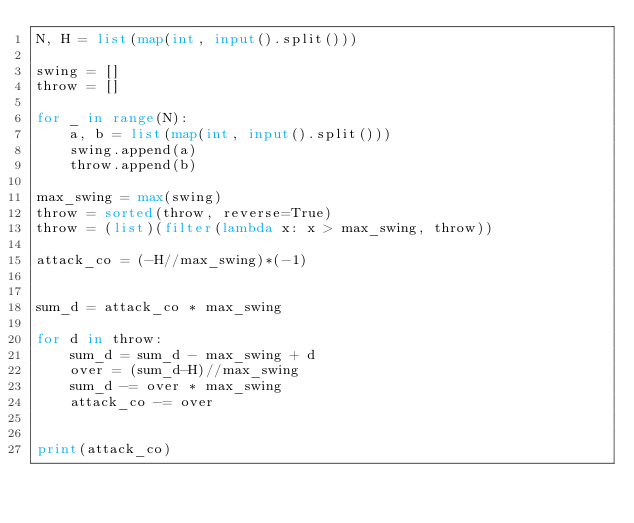<code> <loc_0><loc_0><loc_500><loc_500><_Python_>N, H = list(map(int, input().split()))

swing = []
throw = []

for _ in range(N):
    a, b = list(map(int, input().split()))
    swing.append(a)
    throw.append(b)

max_swing = max(swing)
throw = sorted(throw, reverse=True)
throw = (list)(filter(lambda x: x > max_swing, throw))

attack_co = (-H//max_swing)*(-1)


sum_d = attack_co * max_swing

for d in throw:
    sum_d = sum_d - max_swing + d
    over = (sum_d-H)//max_swing
    sum_d -= over * max_swing
    attack_co -= over


print(attack_co)
</code> 